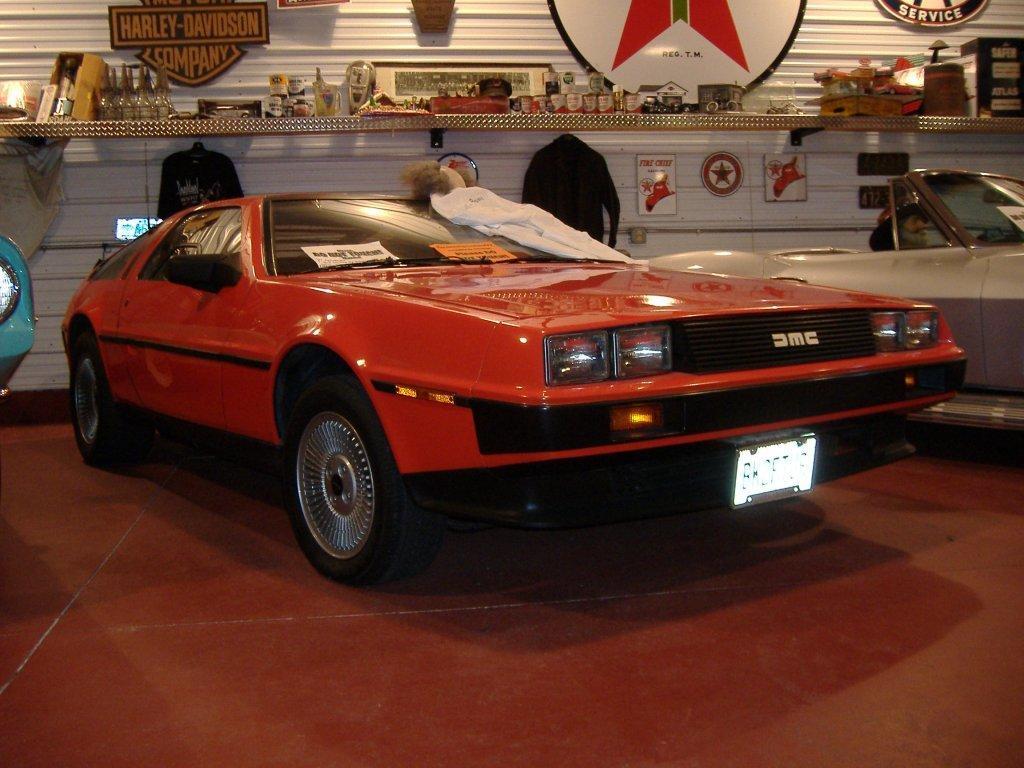Describe this image in one or two sentences. In this image I can see three cars in the center of the image and some objects placed on a wooden shelf and there are some shirts hanging with wall posters and there is a hanging with some text. 